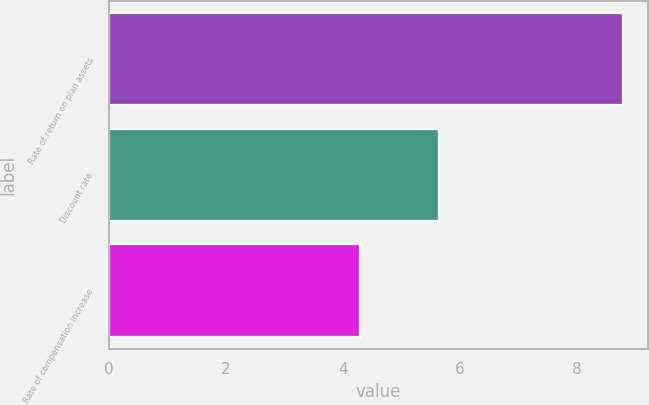Convert chart to OTSL. <chart><loc_0><loc_0><loc_500><loc_500><bar_chart><fcel>Rate of return on plan assets<fcel>Discount rate<fcel>Rate of compensation increase<nl><fcel>8.78<fcel>5.65<fcel>4.3<nl></chart> 